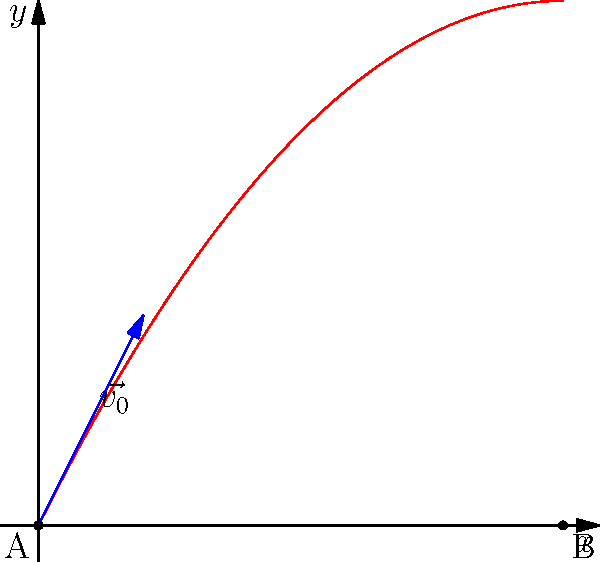A traditional African throwing weapon is launched from point A (0,0) with an initial velocity vector $\vec{v_0} = 2\hat{i} + 4\hat{j}$ (in m/s). The weapon follows a parabolic trajectory described by the equation $y = -0.1x^2 + 2x$. Calculate the horizontal distance traveled by the weapon before it hits the ground at point B. To solve this problem, we need to follow these steps:

1) The trajectory equation is given as $y = -0.1x^2 + 2x$.

2) We need to find the x-coordinate of point B, which is where the weapon hits the ground. At this point, y = 0.

3) Let's solve the equation:
   $0 = -0.1x^2 + 2x$
   $0.1x^2 - 2x = 0$
   $x(0.1x - 2) = 0$

4) This equation has two solutions:
   $x = 0$ (which is the starting point A)
   $0.1x - 2 = 0$
   $0.1x = 2$
   $x = 20$

5) The second solution, $x = 20$, represents the x-coordinate of point B.

Therefore, the horizontal distance traveled by the weapon is 20 meters.
Answer: 20 meters 